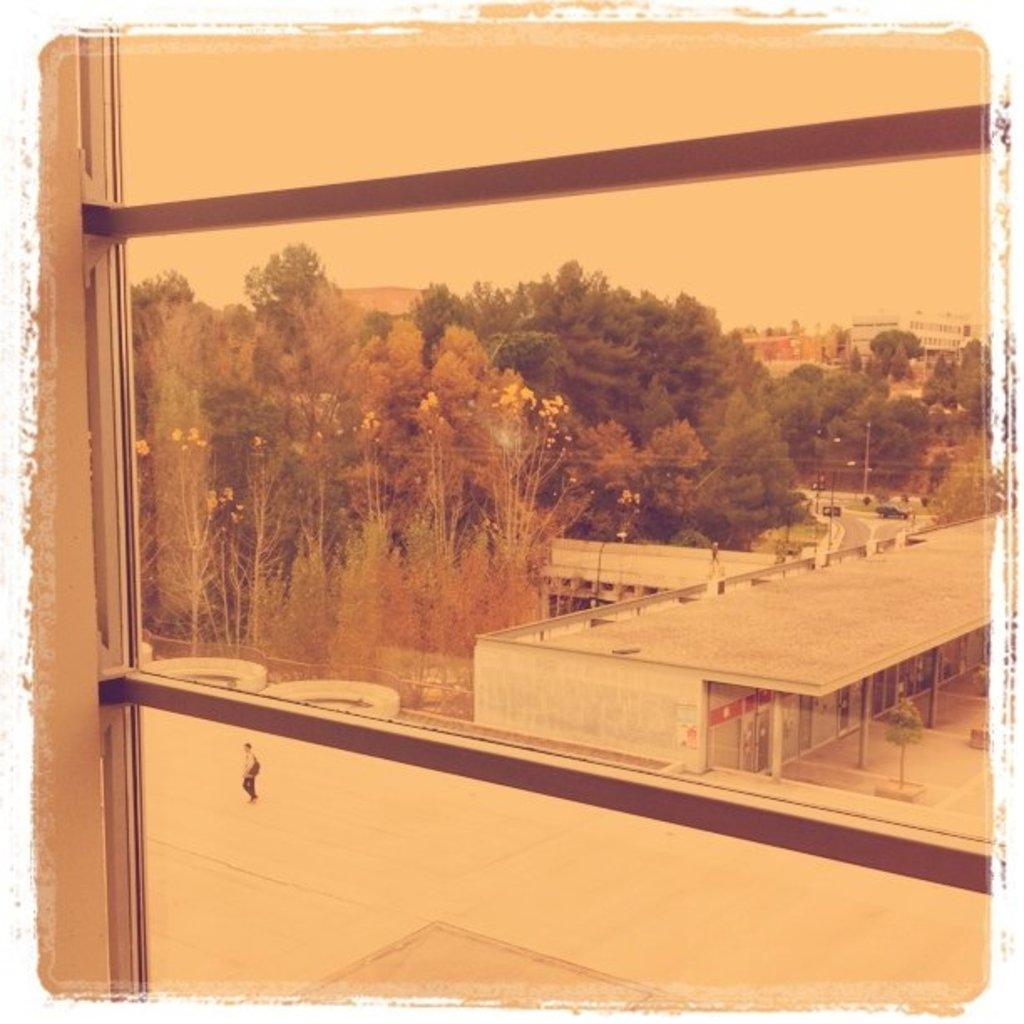What is the medium through which the image is viewed? The image is viewed through a glass. What can be seen in the foreground of the image? There is a small boy walking in the ground. What structures are visible in the background of the image? There is a shed and trees in the background. What type of jewel can be seen in the mouth of the small boy in the image? There is no jewel visible in the mouth of the small boy in the image. How many boats are present in the image? There are no boats present in the image. 